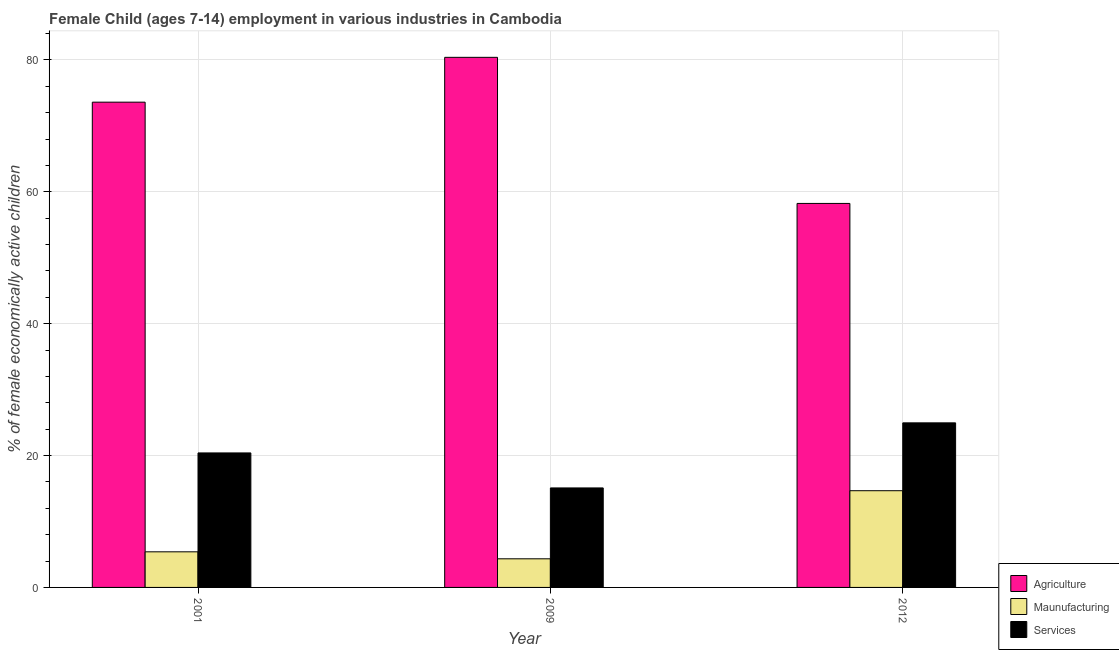How many different coloured bars are there?
Your response must be concise. 3. Are the number of bars per tick equal to the number of legend labels?
Offer a terse response. Yes. How many bars are there on the 3rd tick from the left?
Provide a short and direct response. 3. How many bars are there on the 2nd tick from the right?
Ensure brevity in your answer.  3. In how many cases, is the number of bars for a given year not equal to the number of legend labels?
Give a very brief answer. 0. What is the percentage of economically active children in agriculture in 2001?
Provide a short and direct response. 73.6. Across all years, what is the maximum percentage of economically active children in agriculture?
Your answer should be compact. 80.4. Across all years, what is the minimum percentage of economically active children in services?
Offer a very short reply. 15.09. In which year was the percentage of economically active children in services maximum?
Your answer should be very brief. 2012. In which year was the percentage of economically active children in agriculture minimum?
Your answer should be very brief. 2012. What is the total percentage of economically active children in services in the graph?
Your answer should be very brief. 60.45. What is the difference between the percentage of economically active children in services in 2009 and that in 2012?
Provide a succinct answer. -9.87. What is the difference between the percentage of economically active children in services in 2001 and the percentage of economically active children in agriculture in 2012?
Make the answer very short. -4.56. What is the average percentage of economically active children in services per year?
Give a very brief answer. 20.15. What is the ratio of the percentage of economically active children in services in 2001 to that in 2009?
Offer a terse response. 1.35. Is the difference between the percentage of economically active children in agriculture in 2009 and 2012 greater than the difference between the percentage of economically active children in manufacturing in 2009 and 2012?
Make the answer very short. No. What is the difference between the highest and the second highest percentage of economically active children in services?
Keep it short and to the point. 4.56. What is the difference between the highest and the lowest percentage of economically active children in manufacturing?
Give a very brief answer. 10.33. What does the 3rd bar from the left in 2001 represents?
Ensure brevity in your answer.  Services. What does the 2nd bar from the right in 2012 represents?
Offer a very short reply. Maunufacturing. Is it the case that in every year, the sum of the percentage of economically active children in agriculture and percentage of economically active children in manufacturing is greater than the percentage of economically active children in services?
Your response must be concise. Yes. Are all the bars in the graph horizontal?
Give a very brief answer. No. How many years are there in the graph?
Offer a terse response. 3. Are the values on the major ticks of Y-axis written in scientific E-notation?
Ensure brevity in your answer.  No. Does the graph contain any zero values?
Keep it short and to the point. No. Where does the legend appear in the graph?
Give a very brief answer. Bottom right. How many legend labels are there?
Your response must be concise. 3. What is the title of the graph?
Offer a terse response. Female Child (ages 7-14) employment in various industries in Cambodia. What is the label or title of the Y-axis?
Your answer should be compact. % of female economically active children. What is the % of female economically active children of Agriculture in 2001?
Provide a succinct answer. 73.6. What is the % of female economically active children in Maunufacturing in 2001?
Make the answer very short. 5.4. What is the % of female economically active children of Services in 2001?
Give a very brief answer. 20.4. What is the % of female economically active children in Agriculture in 2009?
Give a very brief answer. 80.4. What is the % of female economically active children of Maunufacturing in 2009?
Your answer should be very brief. 4.34. What is the % of female economically active children in Services in 2009?
Offer a terse response. 15.09. What is the % of female economically active children in Agriculture in 2012?
Your answer should be compact. 58.24. What is the % of female economically active children of Maunufacturing in 2012?
Offer a terse response. 14.67. What is the % of female economically active children in Services in 2012?
Provide a short and direct response. 24.96. Across all years, what is the maximum % of female economically active children of Agriculture?
Offer a terse response. 80.4. Across all years, what is the maximum % of female economically active children of Maunufacturing?
Provide a short and direct response. 14.67. Across all years, what is the maximum % of female economically active children of Services?
Your answer should be very brief. 24.96. Across all years, what is the minimum % of female economically active children of Agriculture?
Your response must be concise. 58.24. Across all years, what is the minimum % of female economically active children of Maunufacturing?
Offer a terse response. 4.34. Across all years, what is the minimum % of female economically active children in Services?
Ensure brevity in your answer.  15.09. What is the total % of female economically active children of Agriculture in the graph?
Your answer should be compact. 212.24. What is the total % of female economically active children in Maunufacturing in the graph?
Provide a short and direct response. 24.41. What is the total % of female economically active children in Services in the graph?
Provide a succinct answer. 60.45. What is the difference between the % of female economically active children in Agriculture in 2001 and that in 2009?
Make the answer very short. -6.8. What is the difference between the % of female economically active children of Maunufacturing in 2001 and that in 2009?
Provide a short and direct response. 1.06. What is the difference between the % of female economically active children of Services in 2001 and that in 2009?
Give a very brief answer. 5.31. What is the difference between the % of female economically active children of Agriculture in 2001 and that in 2012?
Your answer should be compact. 15.36. What is the difference between the % of female economically active children in Maunufacturing in 2001 and that in 2012?
Your answer should be compact. -9.27. What is the difference between the % of female economically active children in Services in 2001 and that in 2012?
Your answer should be compact. -4.56. What is the difference between the % of female economically active children of Agriculture in 2009 and that in 2012?
Offer a very short reply. 22.16. What is the difference between the % of female economically active children in Maunufacturing in 2009 and that in 2012?
Provide a short and direct response. -10.33. What is the difference between the % of female economically active children in Services in 2009 and that in 2012?
Your answer should be compact. -9.87. What is the difference between the % of female economically active children in Agriculture in 2001 and the % of female economically active children in Maunufacturing in 2009?
Provide a short and direct response. 69.26. What is the difference between the % of female economically active children of Agriculture in 2001 and the % of female economically active children of Services in 2009?
Your answer should be compact. 58.51. What is the difference between the % of female economically active children of Maunufacturing in 2001 and the % of female economically active children of Services in 2009?
Provide a succinct answer. -9.69. What is the difference between the % of female economically active children in Agriculture in 2001 and the % of female economically active children in Maunufacturing in 2012?
Provide a short and direct response. 58.93. What is the difference between the % of female economically active children of Agriculture in 2001 and the % of female economically active children of Services in 2012?
Provide a short and direct response. 48.64. What is the difference between the % of female economically active children in Maunufacturing in 2001 and the % of female economically active children in Services in 2012?
Your answer should be compact. -19.56. What is the difference between the % of female economically active children of Agriculture in 2009 and the % of female economically active children of Maunufacturing in 2012?
Provide a short and direct response. 65.73. What is the difference between the % of female economically active children of Agriculture in 2009 and the % of female economically active children of Services in 2012?
Keep it short and to the point. 55.44. What is the difference between the % of female economically active children of Maunufacturing in 2009 and the % of female economically active children of Services in 2012?
Your answer should be compact. -20.62. What is the average % of female economically active children in Agriculture per year?
Make the answer very short. 70.75. What is the average % of female economically active children in Maunufacturing per year?
Offer a terse response. 8.14. What is the average % of female economically active children of Services per year?
Give a very brief answer. 20.15. In the year 2001, what is the difference between the % of female economically active children of Agriculture and % of female economically active children of Maunufacturing?
Your answer should be very brief. 68.2. In the year 2001, what is the difference between the % of female economically active children of Agriculture and % of female economically active children of Services?
Provide a short and direct response. 53.2. In the year 2009, what is the difference between the % of female economically active children in Agriculture and % of female economically active children in Maunufacturing?
Your answer should be compact. 76.06. In the year 2009, what is the difference between the % of female economically active children of Agriculture and % of female economically active children of Services?
Keep it short and to the point. 65.31. In the year 2009, what is the difference between the % of female economically active children in Maunufacturing and % of female economically active children in Services?
Make the answer very short. -10.75. In the year 2012, what is the difference between the % of female economically active children of Agriculture and % of female economically active children of Maunufacturing?
Make the answer very short. 43.57. In the year 2012, what is the difference between the % of female economically active children in Agriculture and % of female economically active children in Services?
Provide a short and direct response. 33.28. In the year 2012, what is the difference between the % of female economically active children in Maunufacturing and % of female economically active children in Services?
Your response must be concise. -10.29. What is the ratio of the % of female economically active children of Agriculture in 2001 to that in 2009?
Your answer should be very brief. 0.92. What is the ratio of the % of female economically active children in Maunufacturing in 2001 to that in 2009?
Offer a very short reply. 1.24. What is the ratio of the % of female economically active children in Services in 2001 to that in 2009?
Your response must be concise. 1.35. What is the ratio of the % of female economically active children of Agriculture in 2001 to that in 2012?
Offer a terse response. 1.26. What is the ratio of the % of female economically active children of Maunufacturing in 2001 to that in 2012?
Offer a very short reply. 0.37. What is the ratio of the % of female economically active children in Services in 2001 to that in 2012?
Your response must be concise. 0.82. What is the ratio of the % of female economically active children of Agriculture in 2009 to that in 2012?
Your answer should be very brief. 1.38. What is the ratio of the % of female economically active children in Maunufacturing in 2009 to that in 2012?
Provide a short and direct response. 0.3. What is the ratio of the % of female economically active children of Services in 2009 to that in 2012?
Keep it short and to the point. 0.6. What is the difference between the highest and the second highest % of female economically active children in Maunufacturing?
Your response must be concise. 9.27. What is the difference between the highest and the second highest % of female economically active children in Services?
Your answer should be compact. 4.56. What is the difference between the highest and the lowest % of female economically active children in Agriculture?
Provide a succinct answer. 22.16. What is the difference between the highest and the lowest % of female economically active children in Maunufacturing?
Provide a short and direct response. 10.33. What is the difference between the highest and the lowest % of female economically active children in Services?
Your response must be concise. 9.87. 